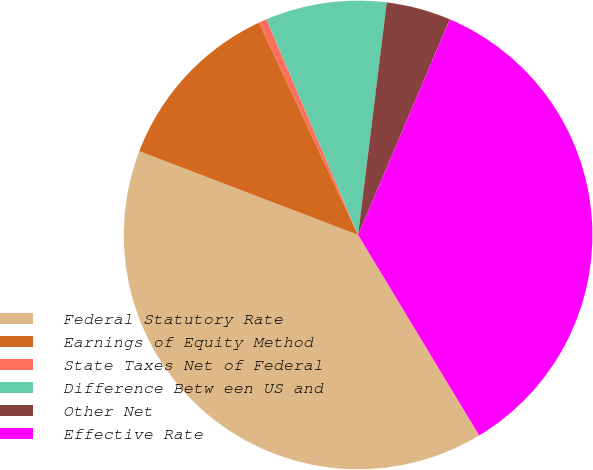Convert chart. <chart><loc_0><loc_0><loc_500><loc_500><pie_chart><fcel>Federal Statutory Rate<fcel>Earnings of Equity Method<fcel>State Taxes Net of Federal<fcel>Difference Betw een US and<fcel>Other Net<fcel>Effective Rate<nl><fcel>39.46%<fcel>12.23%<fcel>0.56%<fcel>8.34%<fcel>4.45%<fcel>34.95%<nl></chart> 